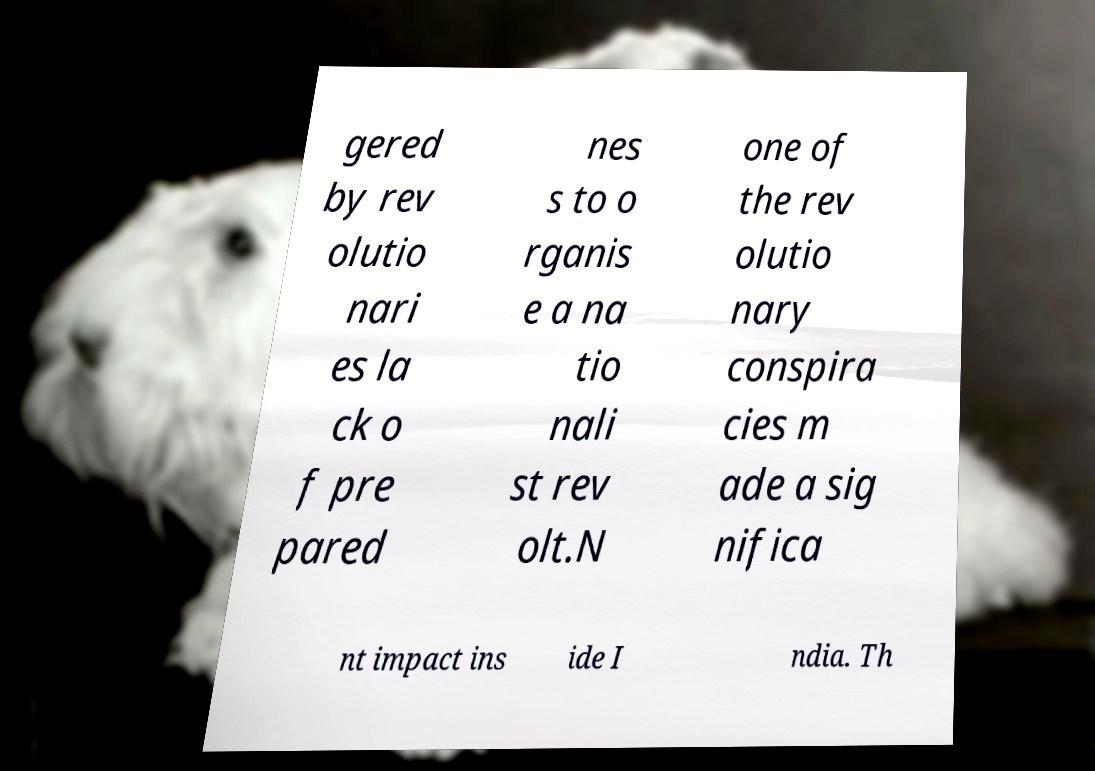Please read and relay the text visible in this image. What does it say? gered by rev olutio nari es la ck o f pre pared nes s to o rganis e a na tio nali st rev olt.N one of the rev olutio nary conspira cies m ade a sig nifica nt impact ins ide I ndia. Th 